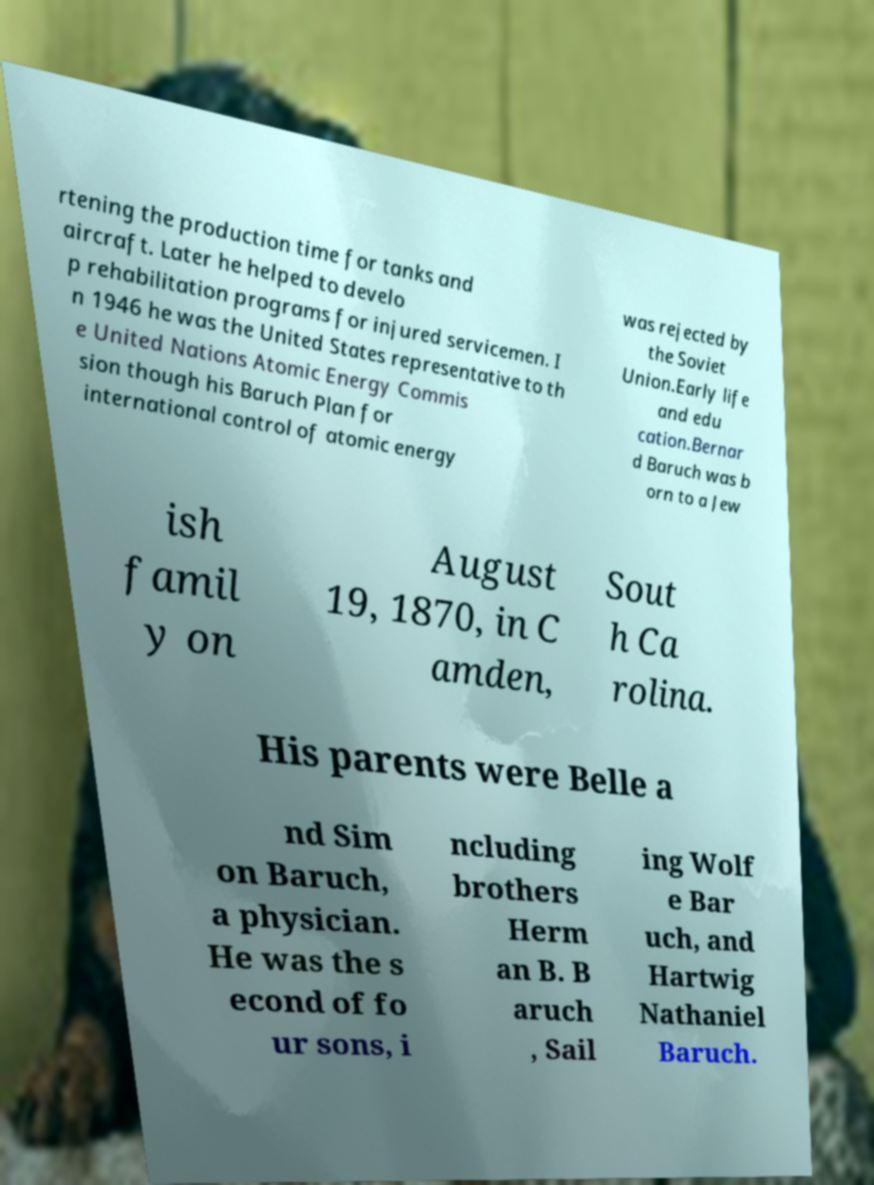For documentation purposes, I need the text within this image transcribed. Could you provide that? rtening the production time for tanks and aircraft. Later he helped to develo p rehabilitation programs for injured servicemen. I n 1946 he was the United States representative to th e United Nations Atomic Energy Commis sion though his Baruch Plan for international control of atomic energy was rejected by the Soviet Union.Early life and edu cation.Bernar d Baruch was b orn to a Jew ish famil y on August 19, 1870, in C amden, Sout h Ca rolina. His parents were Belle a nd Sim on Baruch, a physician. He was the s econd of fo ur sons, i ncluding brothers Herm an B. B aruch , Sail ing Wolf e Bar uch, and Hartwig Nathaniel Baruch. 